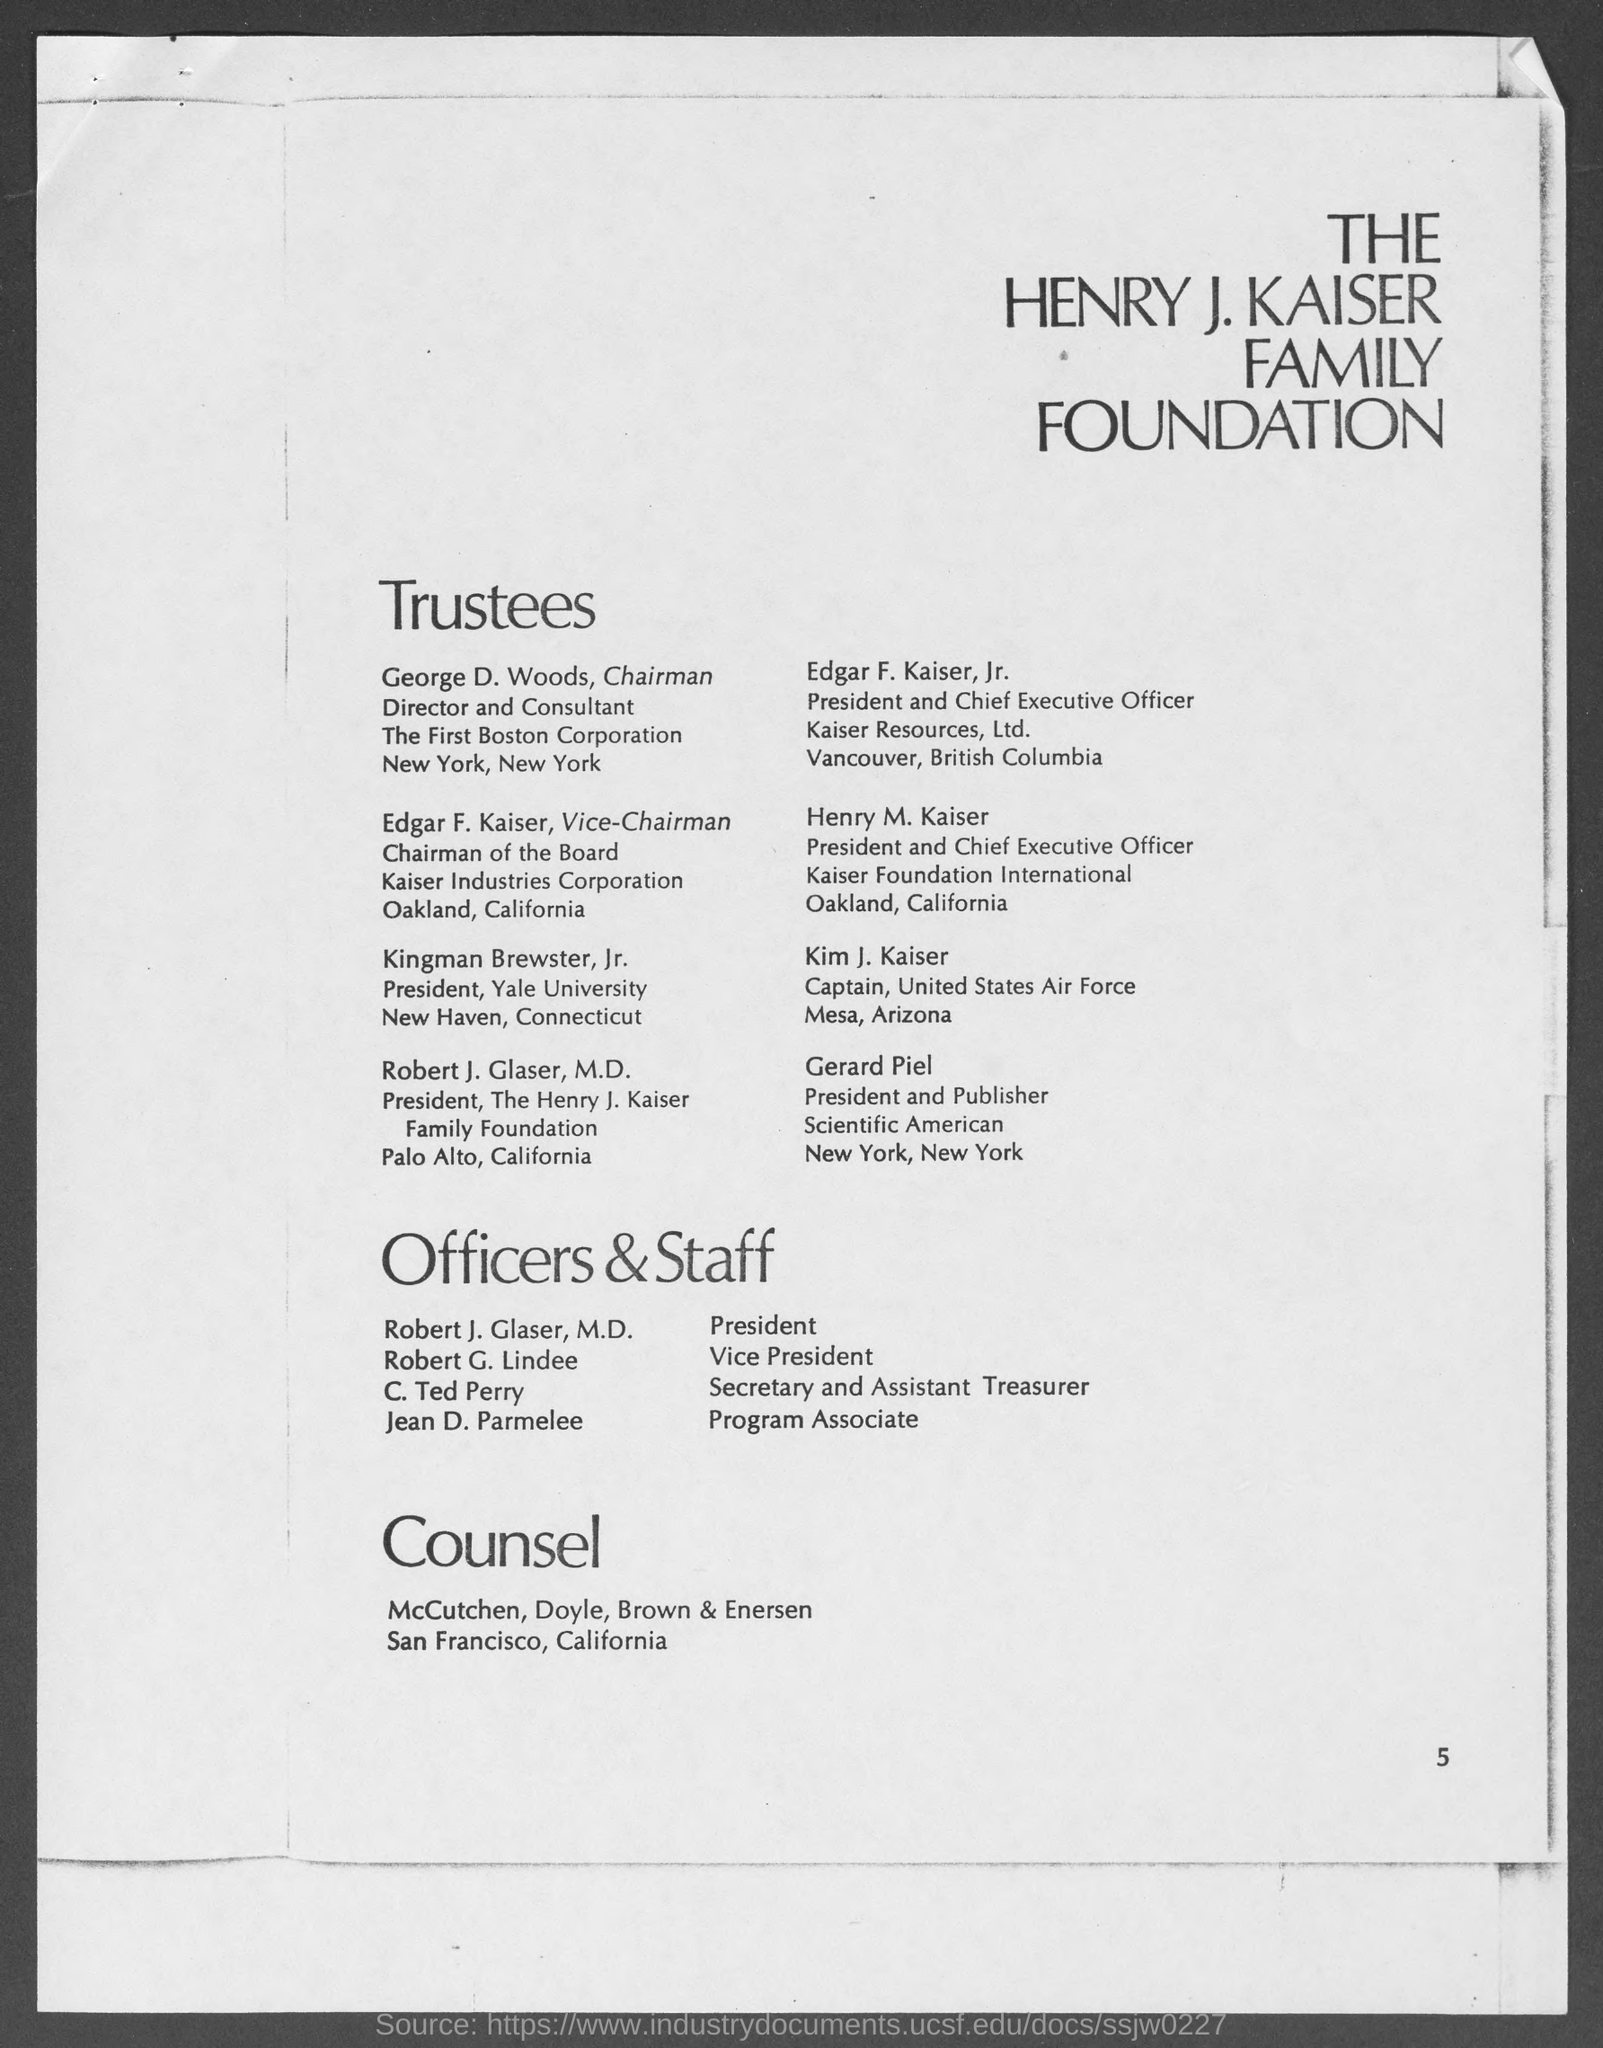Point out several critical features in this image. I want to know the page number at the bottom of the page that is currently on the fifth page. The captain of the United States Air Force is Kim J. Kaiser. Gerard Piel is the President and Publisher of Scientific American. Henry M. Kaiser is the president and Chief Executive Officer of Kaiser Foundation International. Edgar F. Kaiser, Jr. is the President and Chief Executive Officer of Kaiser Resources, Ltd. 